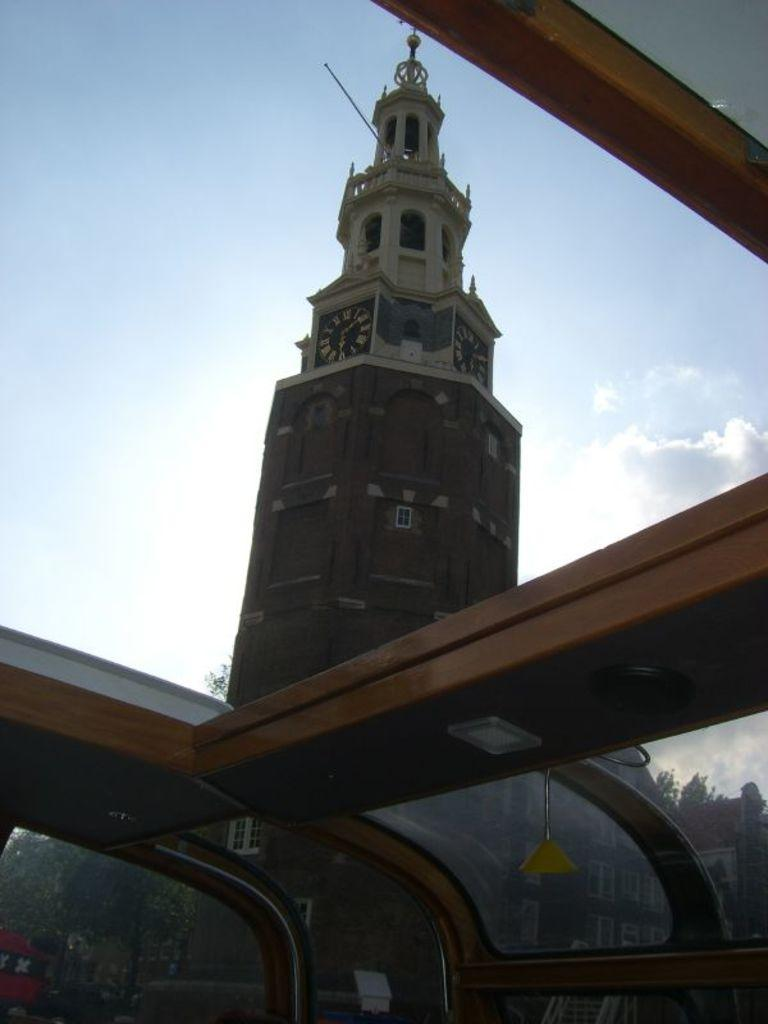What type of structures can be seen in the image? There are buildings in the image. What other natural elements are present in the image? There are trees and clouds in the image. Can you see a kite being flown by someone in the image? There is no kite present in the image. What type of support is provided for the trees in the image? The trees in the image are not shown to have any specific support; they appear to be growing naturally. 